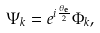<formula> <loc_0><loc_0><loc_500><loc_500>\Psi _ { k } = e ^ { i \frac { \theta _ { \mathbf e } } { 2 } } \Phi _ { k } ,</formula> 